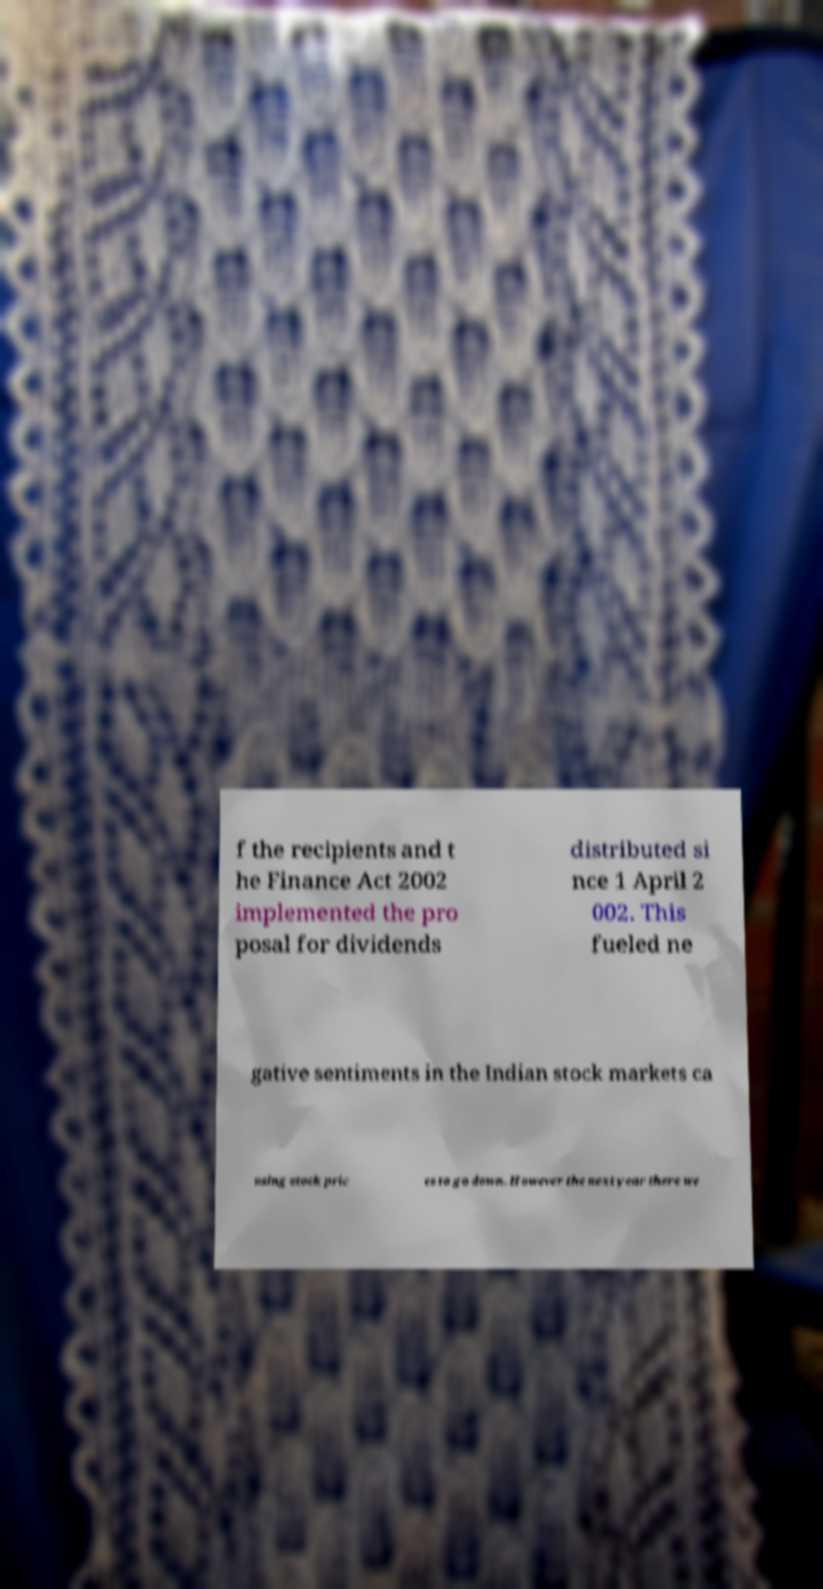Can you accurately transcribe the text from the provided image for me? f the recipients and t he Finance Act 2002 implemented the pro posal for dividends distributed si nce 1 April 2 002. This fueled ne gative sentiments in the Indian stock markets ca using stock pric es to go down. However the next year there we 